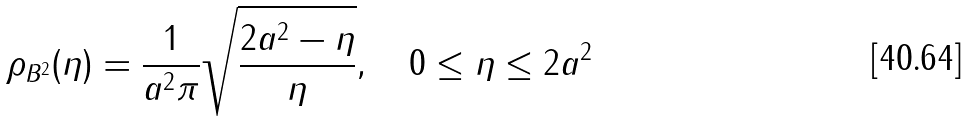<formula> <loc_0><loc_0><loc_500><loc_500>\rho _ { B ^ { 2 } } ( \eta ) = \frac { 1 } { a ^ { 2 } \pi } \sqrt { \frac { 2 a ^ { 2 } - \eta } { \eta } } , \quad 0 \leq \eta \leq 2 a ^ { 2 }</formula> 